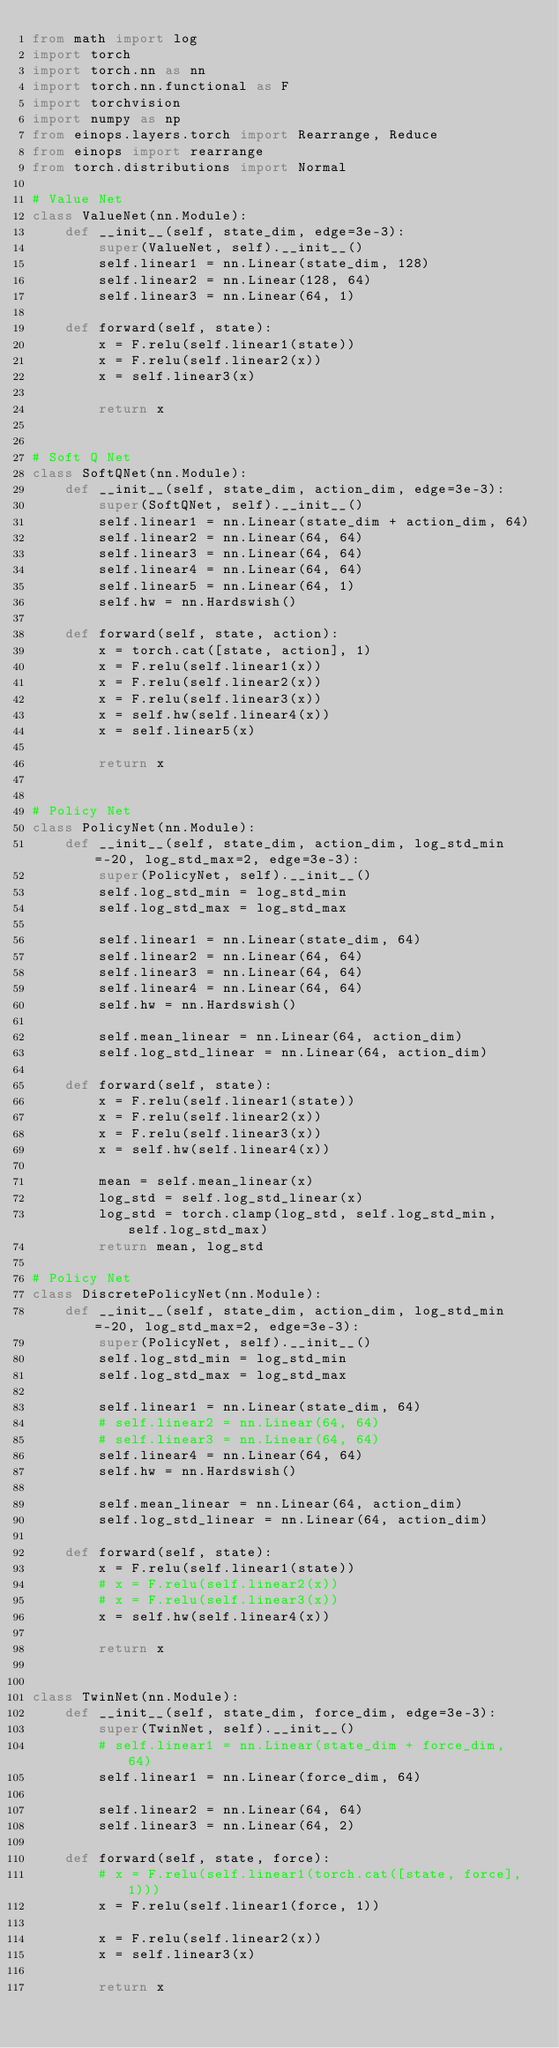<code> <loc_0><loc_0><loc_500><loc_500><_Python_>from math import log
import torch
import torch.nn as nn
import torch.nn.functional as F
import torchvision
import numpy as np
from einops.layers.torch import Rearrange, Reduce
from einops import rearrange
from torch.distributions import Normal

# Value Net
class ValueNet(nn.Module):
    def __init__(self, state_dim, edge=3e-3):
        super(ValueNet, self).__init__()
        self.linear1 = nn.Linear(state_dim, 128)
        self.linear2 = nn.Linear(128, 64)
        self.linear3 = nn.Linear(64, 1)

    def forward(self, state):
        x = F.relu(self.linear1(state))
        x = F.relu(self.linear2(x))
        x = self.linear3(x)

        return x


# Soft Q Net
class SoftQNet(nn.Module):
    def __init__(self, state_dim, action_dim, edge=3e-3):
        super(SoftQNet, self).__init__()
        self.linear1 = nn.Linear(state_dim + action_dim, 64)
        self.linear2 = nn.Linear(64, 64)
        self.linear3 = nn.Linear(64, 64)
        self.linear4 = nn.Linear(64, 64)
        self.linear5 = nn.Linear(64, 1)
        self.hw = nn.Hardswish()

    def forward(self, state, action):
        x = torch.cat([state, action], 1)
        x = F.relu(self.linear1(x))
        x = F.relu(self.linear2(x))
        x = F.relu(self.linear3(x))
        x = self.hw(self.linear4(x))
        x = self.linear5(x)

        return x


# Policy Net
class PolicyNet(nn.Module):
    def __init__(self, state_dim, action_dim, log_std_min=-20, log_std_max=2, edge=3e-3):
        super(PolicyNet, self).__init__()
        self.log_std_min = log_std_min
        self.log_std_max = log_std_max

        self.linear1 = nn.Linear(state_dim, 64)
        self.linear2 = nn.Linear(64, 64)
        self.linear3 = nn.Linear(64, 64)
        self.linear4 = nn.Linear(64, 64)
        self.hw = nn.Hardswish()

        self.mean_linear = nn.Linear(64, action_dim)
        self.log_std_linear = nn.Linear(64, action_dim)

    def forward(self, state):
        x = F.relu(self.linear1(state))
        x = F.relu(self.linear2(x))
        x = F.relu(self.linear3(x))
        x = self.hw(self.linear4(x))

        mean = self.mean_linear(x)
        log_std = self.log_std_linear(x)
        log_std = torch.clamp(log_std, self.log_std_min, self.log_std_max)
        return mean, log_std

# Policy Net
class DiscretePolicyNet(nn.Module):
    def __init__(self, state_dim, action_dim, log_std_min=-20, log_std_max=2, edge=3e-3):
        super(PolicyNet, self).__init__()
        self.log_std_min = log_std_min
        self.log_std_max = log_std_max

        self.linear1 = nn.Linear(state_dim, 64)
        # self.linear2 = nn.Linear(64, 64)
        # self.linear3 = nn.Linear(64, 64)
        self.linear4 = nn.Linear(64, 64)
        self.hw = nn.Hardswish()

        self.mean_linear = nn.Linear(64, action_dim)
        self.log_std_linear = nn.Linear(64, action_dim)

    def forward(self, state):
        x = F.relu(self.linear1(state))
        # x = F.relu(self.linear2(x))
        # x = F.relu(self.linear3(x))
        x = self.hw(self.linear4(x))

        return x


class TwinNet(nn.Module):
    def __init__(self, state_dim, force_dim, edge=3e-3):
        super(TwinNet, self).__init__()
        # self.linear1 = nn.Linear(state_dim + force_dim, 64)
        self.linear1 = nn.Linear(force_dim, 64)

        self.linear2 = nn.Linear(64, 64)
        self.linear3 = nn.Linear(64, 2)

    def forward(self, state, force):
        # x = F.relu(self.linear1(torch.cat([state, force], 1)))
        x = F.relu(self.linear1(force, 1))

        x = F.relu(self.linear2(x))
        x = self.linear3(x)

        return x

        
</code> 